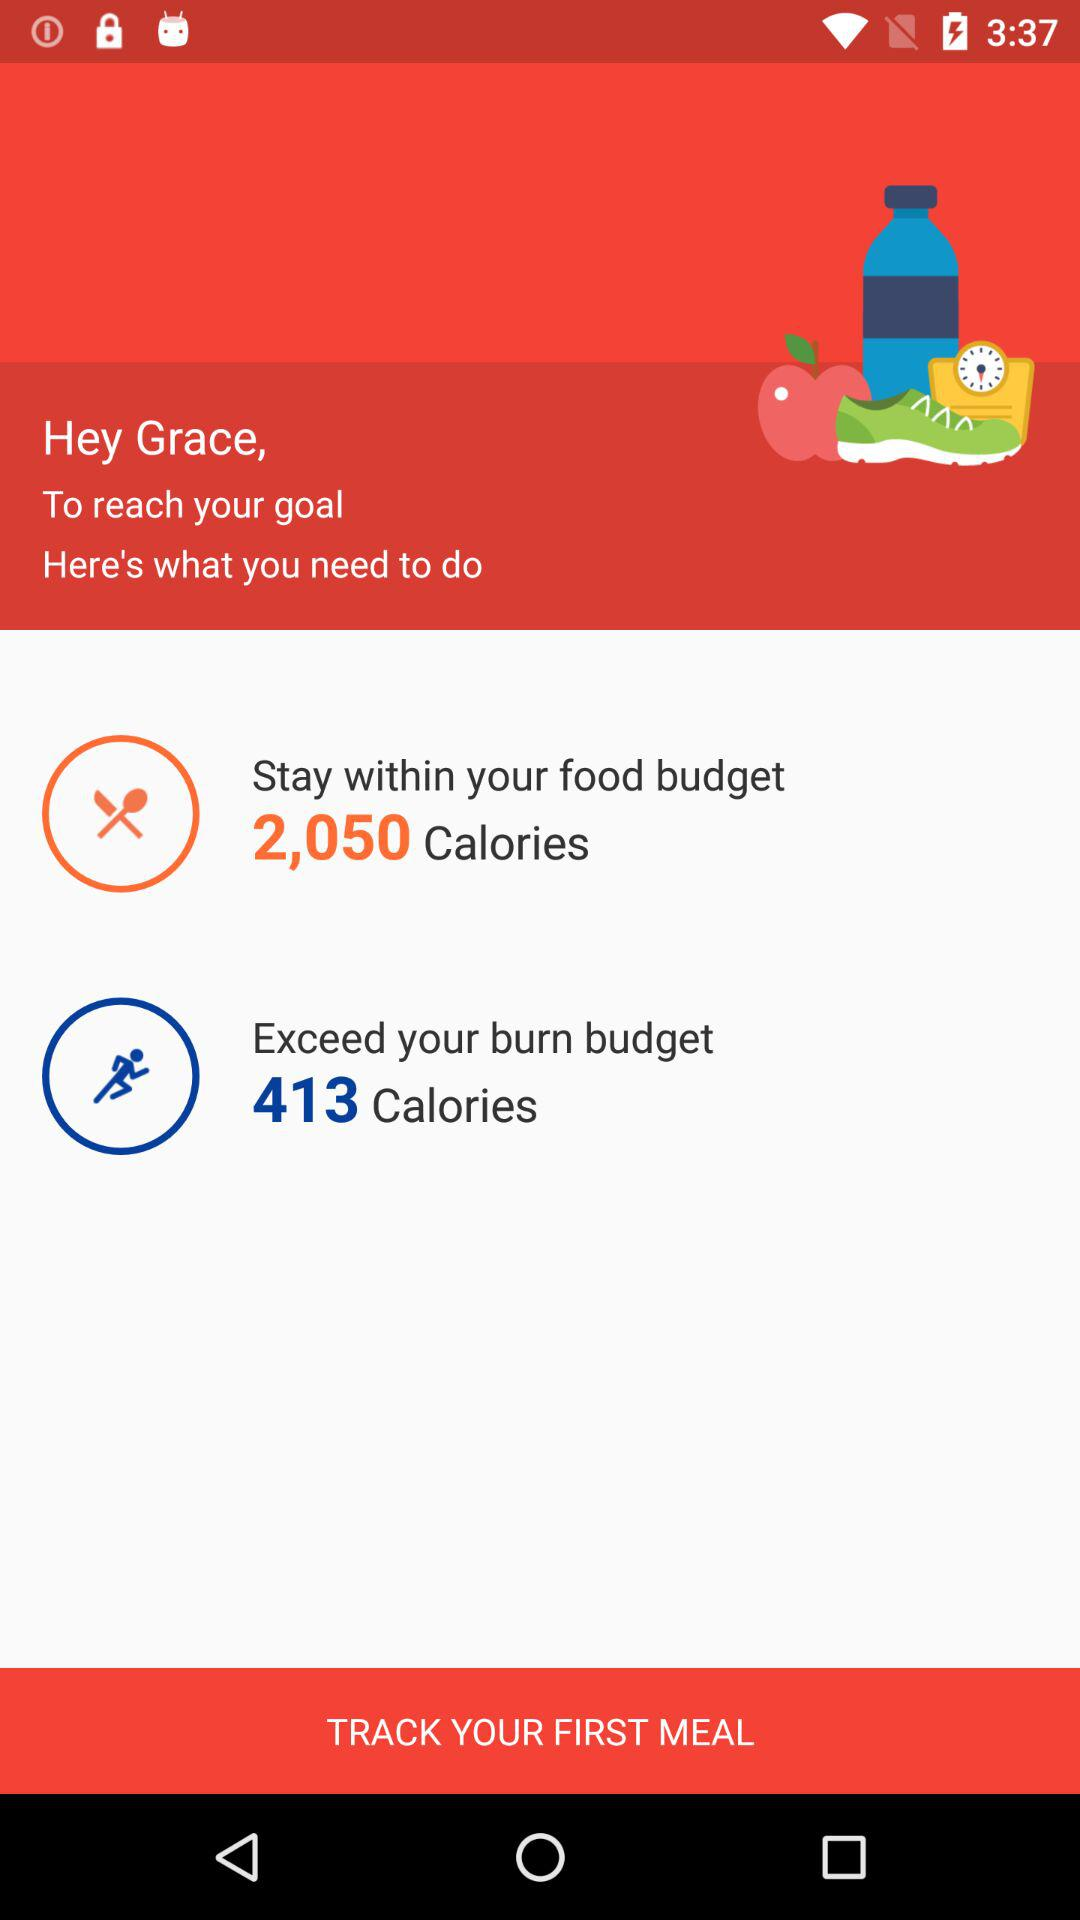How many calories do I need to exceed to reach my goal?
Answer the question using a single word or phrase. 413 